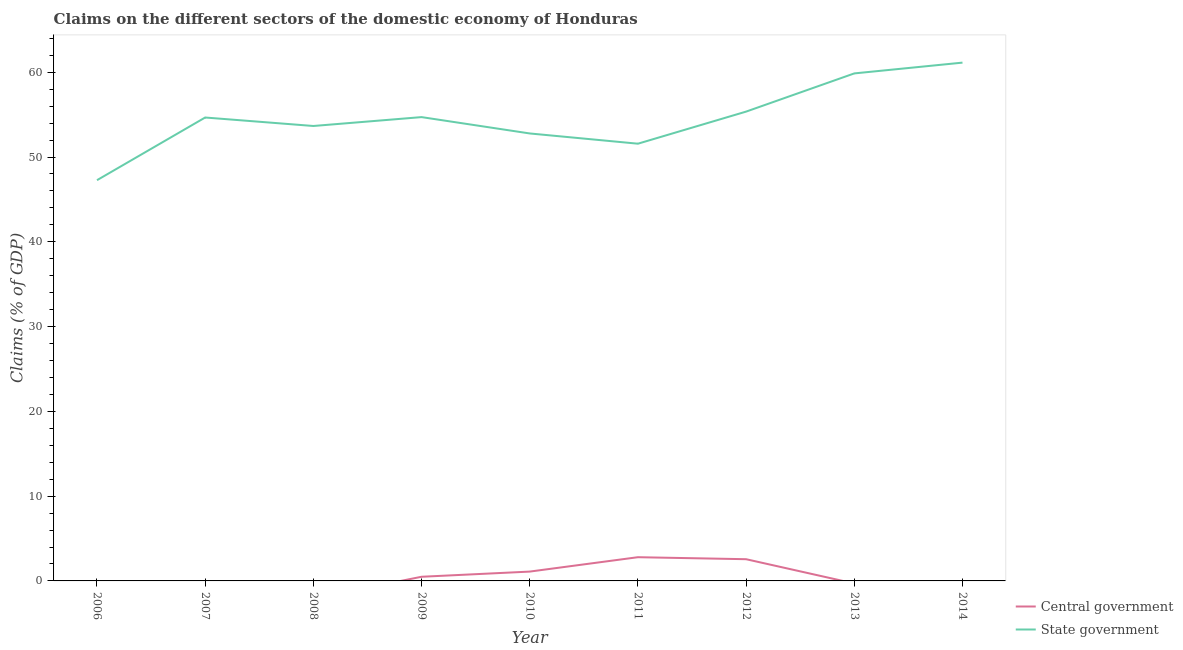How many different coloured lines are there?
Your answer should be compact. 2. Does the line corresponding to claims on central government intersect with the line corresponding to claims on state government?
Keep it short and to the point. No. Is the number of lines equal to the number of legend labels?
Keep it short and to the point. No. What is the claims on central government in 2014?
Provide a succinct answer. 0. Across all years, what is the maximum claims on state government?
Ensure brevity in your answer.  61.14. Across all years, what is the minimum claims on state government?
Provide a short and direct response. 47.27. What is the total claims on state government in the graph?
Offer a terse response. 491.02. What is the difference between the claims on state government in 2009 and that in 2012?
Keep it short and to the point. -0.65. What is the difference between the claims on central government in 2011 and the claims on state government in 2014?
Keep it short and to the point. -58.34. What is the average claims on state government per year?
Your response must be concise. 54.56. In the year 2011, what is the difference between the claims on central government and claims on state government?
Ensure brevity in your answer.  -48.78. In how many years, is the claims on central government greater than 6 %?
Your response must be concise. 0. What is the ratio of the claims on state government in 2006 to that in 2014?
Offer a terse response. 0.77. Is the difference between the claims on central government in 2010 and 2011 greater than the difference between the claims on state government in 2010 and 2011?
Make the answer very short. No. What is the difference between the highest and the second highest claims on state government?
Your answer should be compact. 1.27. What is the difference between the highest and the lowest claims on central government?
Offer a terse response. 2.8. Is the sum of the claims on state government in 2008 and 2012 greater than the maximum claims on central government across all years?
Ensure brevity in your answer.  Yes. Does the claims on state government monotonically increase over the years?
Make the answer very short. No. Is the claims on state government strictly greater than the claims on central government over the years?
Your answer should be compact. Yes. Is the claims on state government strictly less than the claims on central government over the years?
Ensure brevity in your answer.  No. How many lines are there?
Offer a terse response. 2. How many years are there in the graph?
Ensure brevity in your answer.  9. Are the values on the major ticks of Y-axis written in scientific E-notation?
Your response must be concise. No. How many legend labels are there?
Make the answer very short. 2. What is the title of the graph?
Provide a short and direct response. Claims on the different sectors of the domestic economy of Honduras. Does "By country of asylum" appear as one of the legend labels in the graph?
Keep it short and to the point. No. What is the label or title of the X-axis?
Keep it short and to the point. Year. What is the label or title of the Y-axis?
Provide a short and direct response. Claims (% of GDP). What is the Claims (% of GDP) in State government in 2006?
Provide a succinct answer. 47.27. What is the Claims (% of GDP) of Central government in 2007?
Provide a succinct answer. 0. What is the Claims (% of GDP) in State government in 2007?
Your answer should be very brief. 54.66. What is the Claims (% of GDP) of Central government in 2008?
Your response must be concise. 0. What is the Claims (% of GDP) of State government in 2008?
Keep it short and to the point. 53.66. What is the Claims (% of GDP) of Central government in 2009?
Your response must be concise. 0.49. What is the Claims (% of GDP) in State government in 2009?
Provide a succinct answer. 54.71. What is the Claims (% of GDP) in Central government in 2010?
Keep it short and to the point. 1.1. What is the Claims (% of GDP) of State government in 2010?
Offer a terse response. 52.78. What is the Claims (% of GDP) in Central government in 2011?
Keep it short and to the point. 2.8. What is the Claims (% of GDP) in State government in 2011?
Give a very brief answer. 51.57. What is the Claims (% of GDP) of Central government in 2012?
Your response must be concise. 2.56. What is the Claims (% of GDP) in State government in 2012?
Provide a short and direct response. 55.36. What is the Claims (% of GDP) of Central government in 2013?
Ensure brevity in your answer.  0. What is the Claims (% of GDP) in State government in 2013?
Provide a succinct answer. 59.86. What is the Claims (% of GDP) of Central government in 2014?
Make the answer very short. 0. What is the Claims (% of GDP) in State government in 2014?
Your response must be concise. 61.14. Across all years, what is the maximum Claims (% of GDP) of Central government?
Your response must be concise. 2.8. Across all years, what is the maximum Claims (% of GDP) in State government?
Make the answer very short. 61.14. Across all years, what is the minimum Claims (% of GDP) of State government?
Make the answer very short. 47.27. What is the total Claims (% of GDP) of Central government in the graph?
Your response must be concise. 6.95. What is the total Claims (% of GDP) of State government in the graph?
Your response must be concise. 491.02. What is the difference between the Claims (% of GDP) of State government in 2006 and that in 2007?
Make the answer very short. -7.39. What is the difference between the Claims (% of GDP) in State government in 2006 and that in 2008?
Provide a short and direct response. -6.39. What is the difference between the Claims (% of GDP) in State government in 2006 and that in 2009?
Your answer should be compact. -7.44. What is the difference between the Claims (% of GDP) in State government in 2006 and that in 2010?
Your answer should be very brief. -5.51. What is the difference between the Claims (% of GDP) of State government in 2006 and that in 2011?
Keep it short and to the point. -4.31. What is the difference between the Claims (% of GDP) in State government in 2006 and that in 2012?
Give a very brief answer. -8.09. What is the difference between the Claims (% of GDP) in State government in 2006 and that in 2013?
Provide a short and direct response. -12.6. What is the difference between the Claims (% of GDP) of State government in 2006 and that in 2014?
Your answer should be very brief. -13.87. What is the difference between the Claims (% of GDP) of State government in 2007 and that in 2009?
Keep it short and to the point. -0.05. What is the difference between the Claims (% of GDP) in State government in 2007 and that in 2010?
Keep it short and to the point. 1.88. What is the difference between the Claims (% of GDP) of State government in 2007 and that in 2011?
Your answer should be compact. 3.09. What is the difference between the Claims (% of GDP) of State government in 2007 and that in 2012?
Provide a succinct answer. -0.7. What is the difference between the Claims (% of GDP) in State government in 2007 and that in 2013?
Your answer should be very brief. -5.2. What is the difference between the Claims (% of GDP) in State government in 2007 and that in 2014?
Give a very brief answer. -6.47. What is the difference between the Claims (% of GDP) in State government in 2008 and that in 2009?
Offer a terse response. -1.05. What is the difference between the Claims (% of GDP) of State government in 2008 and that in 2010?
Make the answer very short. 0.88. What is the difference between the Claims (% of GDP) of State government in 2008 and that in 2011?
Offer a terse response. 2.09. What is the difference between the Claims (% of GDP) of State government in 2008 and that in 2012?
Ensure brevity in your answer.  -1.7. What is the difference between the Claims (% of GDP) of State government in 2008 and that in 2013?
Your answer should be very brief. -6.2. What is the difference between the Claims (% of GDP) of State government in 2008 and that in 2014?
Your answer should be very brief. -7.47. What is the difference between the Claims (% of GDP) in Central government in 2009 and that in 2010?
Offer a terse response. -0.61. What is the difference between the Claims (% of GDP) of State government in 2009 and that in 2010?
Ensure brevity in your answer.  1.93. What is the difference between the Claims (% of GDP) in Central government in 2009 and that in 2011?
Ensure brevity in your answer.  -2.31. What is the difference between the Claims (% of GDP) in State government in 2009 and that in 2011?
Offer a terse response. 3.14. What is the difference between the Claims (% of GDP) in Central government in 2009 and that in 2012?
Give a very brief answer. -2.07. What is the difference between the Claims (% of GDP) in State government in 2009 and that in 2012?
Offer a very short reply. -0.65. What is the difference between the Claims (% of GDP) of State government in 2009 and that in 2013?
Give a very brief answer. -5.16. What is the difference between the Claims (% of GDP) of State government in 2009 and that in 2014?
Your answer should be compact. -6.43. What is the difference between the Claims (% of GDP) of Central government in 2010 and that in 2011?
Make the answer very short. -1.7. What is the difference between the Claims (% of GDP) in State government in 2010 and that in 2011?
Provide a succinct answer. 1.21. What is the difference between the Claims (% of GDP) of Central government in 2010 and that in 2012?
Ensure brevity in your answer.  -1.46. What is the difference between the Claims (% of GDP) in State government in 2010 and that in 2012?
Offer a very short reply. -2.58. What is the difference between the Claims (% of GDP) of State government in 2010 and that in 2013?
Offer a very short reply. -7.08. What is the difference between the Claims (% of GDP) in State government in 2010 and that in 2014?
Your response must be concise. -8.35. What is the difference between the Claims (% of GDP) in Central government in 2011 and that in 2012?
Offer a very short reply. 0.24. What is the difference between the Claims (% of GDP) in State government in 2011 and that in 2012?
Your answer should be very brief. -3.79. What is the difference between the Claims (% of GDP) in State government in 2011 and that in 2013?
Offer a very short reply. -8.29. What is the difference between the Claims (% of GDP) of State government in 2011 and that in 2014?
Your response must be concise. -9.56. What is the difference between the Claims (% of GDP) of State government in 2012 and that in 2013?
Offer a very short reply. -4.51. What is the difference between the Claims (% of GDP) in State government in 2012 and that in 2014?
Give a very brief answer. -5.78. What is the difference between the Claims (% of GDP) of State government in 2013 and that in 2014?
Ensure brevity in your answer.  -1.27. What is the difference between the Claims (% of GDP) in Central government in 2009 and the Claims (% of GDP) in State government in 2010?
Offer a very short reply. -52.29. What is the difference between the Claims (% of GDP) of Central government in 2009 and the Claims (% of GDP) of State government in 2011?
Ensure brevity in your answer.  -51.08. What is the difference between the Claims (% of GDP) of Central government in 2009 and the Claims (% of GDP) of State government in 2012?
Provide a short and direct response. -54.87. What is the difference between the Claims (% of GDP) in Central government in 2009 and the Claims (% of GDP) in State government in 2013?
Provide a short and direct response. -59.37. What is the difference between the Claims (% of GDP) of Central government in 2009 and the Claims (% of GDP) of State government in 2014?
Your answer should be very brief. -60.65. What is the difference between the Claims (% of GDP) in Central government in 2010 and the Claims (% of GDP) in State government in 2011?
Your answer should be compact. -50.47. What is the difference between the Claims (% of GDP) in Central government in 2010 and the Claims (% of GDP) in State government in 2012?
Your response must be concise. -54.26. What is the difference between the Claims (% of GDP) in Central government in 2010 and the Claims (% of GDP) in State government in 2013?
Your response must be concise. -58.76. What is the difference between the Claims (% of GDP) in Central government in 2010 and the Claims (% of GDP) in State government in 2014?
Offer a very short reply. -60.04. What is the difference between the Claims (% of GDP) of Central government in 2011 and the Claims (% of GDP) of State government in 2012?
Offer a very short reply. -52.56. What is the difference between the Claims (% of GDP) in Central government in 2011 and the Claims (% of GDP) in State government in 2013?
Offer a terse response. -57.07. What is the difference between the Claims (% of GDP) in Central government in 2011 and the Claims (% of GDP) in State government in 2014?
Ensure brevity in your answer.  -58.34. What is the difference between the Claims (% of GDP) of Central government in 2012 and the Claims (% of GDP) of State government in 2013?
Offer a terse response. -57.3. What is the difference between the Claims (% of GDP) of Central government in 2012 and the Claims (% of GDP) of State government in 2014?
Your answer should be very brief. -58.57. What is the average Claims (% of GDP) in Central government per year?
Make the answer very short. 0.77. What is the average Claims (% of GDP) in State government per year?
Offer a very short reply. 54.56. In the year 2009, what is the difference between the Claims (% of GDP) of Central government and Claims (% of GDP) of State government?
Give a very brief answer. -54.22. In the year 2010, what is the difference between the Claims (% of GDP) of Central government and Claims (% of GDP) of State government?
Your response must be concise. -51.68. In the year 2011, what is the difference between the Claims (% of GDP) of Central government and Claims (% of GDP) of State government?
Your answer should be very brief. -48.78. In the year 2012, what is the difference between the Claims (% of GDP) of Central government and Claims (% of GDP) of State government?
Offer a very short reply. -52.8. What is the ratio of the Claims (% of GDP) in State government in 2006 to that in 2007?
Offer a terse response. 0.86. What is the ratio of the Claims (% of GDP) in State government in 2006 to that in 2008?
Give a very brief answer. 0.88. What is the ratio of the Claims (% of GDP) of State government in 2006 to that in 2009?
Offer a very short reply. 0.86. What is the ratio of the Claims (% of GDP) of State government in 2006 to that in 2010?
Give a very brief answer. 0.9. What is the ratio of the Claims (% of GDP) of State government in 2006 to that in 2011?
Offer a very short reply. 0.92. What is the ratio of the Claims (% of GDP) of State government in 2006 to that in 2012?
Give a very brief answer. 0.85. What is the ratio of the Claims (% of GDP) in State government in 2006 to that in 2013?
Offer a very short reply. 0.79. What is the ratio of the Claims (% of GDP) in State government in 2006 to that in 2014?
Make the answer very short. 0.77. What is the ratio of the Claims (% of GDP) in State government in 2007 to that in 2008?
Ensure brevity in your answer.  1.02. What is the ratio of the Claims (% of GDP) in State government in 2007 to that in 2010?
Give a very brief answer. 1.04. What is the ratio of the Claims (% of GDP) of State government in 2007 to that in 2011?
Offer a terse response. 1.06. What is the ratio of the Claims (% of GDP) in State government in 2007 to that in 2012?
Your response must be concise. 0.99. What is the ratio of the Claims (% of GDP) of State government in 2007 to that in 2013?
Make the answer very short. 0.91. What is the ratio of the Claims (% of GDP) in State government in 2007 to that in 2014?
Offer a very short reply. 0.89. What is the ratio of the Claims (% of GDP) of State government in 2008 to that in 2009?
Give a very brief answer. 0.98. What is the ratio of the Claims (% of GDP) in State government in 2008 to that in 2010?
Your answer should be very brief. 1.02. What is the ratio of the Claims (% of GDP) in State government in 2008 to that in 2011?
Your answer should be very brief. 1.04. What is the ratio of the Claims (% of GDP) of State government in 2008 to that in 2012?
Keep it short and to the point. 0.97. What is the ratio of the Claims (% of GDP) of State government in 2008 to that in 2013?
Provide a succinct answer. 0.9. What is the ratio of the Claims (% of GDP) in State government in 2008 to that in 2014?
Provide a short and direct response. 0.88. What is the ratio of the Claims (% of GDP) of Central government in 2009 to that in 2010?
Offer a terse response. 0.45. What is the ratio of the Claims (% of GDP) in State government in 2009 to that in 2010?
Your response must be concise. 1.04. What is the ratio of the Claims (% of GDP) in Central government in 2009 to that in 2011?
Your answer should be very brief. 0.18. What is the ratio of the Claims (% of GDP) of State government in 2009 to that in 2011?
Offer a very short reply. 1.06. What is the ratio of the Claims (% of GDP) in Central government in 2009 to that in 2012?
Keep it short and to the point. 0.19. What is the ratio of the Claims (% of GDP) of State government in 2009 to that in 2012?
Keep it short and to the point. 0.99. What is the ratio of the Claims (% of GDP) of State government in 2009 to that in 2013?
Your answer should be very brief. 0.91. What is the ratio of the Claims (% of GDP) in State government in 2009 to that in 2014?
Give a very brief answer. 0.89. What is the ratio of the Claims (% of GDP) in Central government in 2010 to that in 2011?
Offer a terse response. 0.39. What is the ratio of the Claims (% of GDP) of State government in 2010 to that in 2011?
Provide a short and direct response. 1.02. What is the ratio of the Claims (% of GDP) of Central government in 2010 to that in 2012?
Provide a succinct answer. 0.43. What is the ratio of the Claims (% of GDP) of State government in 2010 to that in 2012?
Ensure brevity in your answer.  0.95. What is the ratio of the Claims (% of GDP) of State government in 2010 to that in 2013?
Provide a short and direct response. 0.88. What is the ratio of the Claims (% of GDP) in State government in 2010 to that in 2014?
Provide a short and direct response. 0.86. What is the ratio of the Claims (% of GDP) of Central government in 2011 to that in 2012?
Keep it short and to the point. 1.09. What is the ratio of the Claims (% of GDP) in State government in 2011 to that in 2012?
Ensure brevity in your answer.  0.93. What is the ratio of the Claims (% of GDP) of State government in 2011 to that in 2013?
Your response must be concise. 0.86. What is the ratio of the Claims (% of GDP) of State government in 2011 to that in 2014?
Provide a short and direct response. 0.84. What is the ratio of the Claims (% of GDP) in State government in 2012 to that in 2013?
Ensure brevity in your answer.  0.92. What is the ratio of the Claims (% of GDP) of State government in 2012 to that in 2014?
Offer a very short reply. 0.91. What is the ratio of the Claims (% of GDP) of State government in 2013 to that in 2014?
Ensure brevity in your answer.  0.98. What is the difference between the highest and the second highest Claims (% of GDP) of Central government?
Your response must be concise. 0.24. What is the difference between the highest and the second highest Claims (% of GDP) in State government?
Ensure brevity in your answer.  1.27. What is the difference between the highest and the lowest Claims (% of GDP) in Central government?
Provide a succinct answer. 2.8. What is the difference between the highest and the lowest Claims (% of GDP) of State government?
Provide a succinct answer. 13.87. 